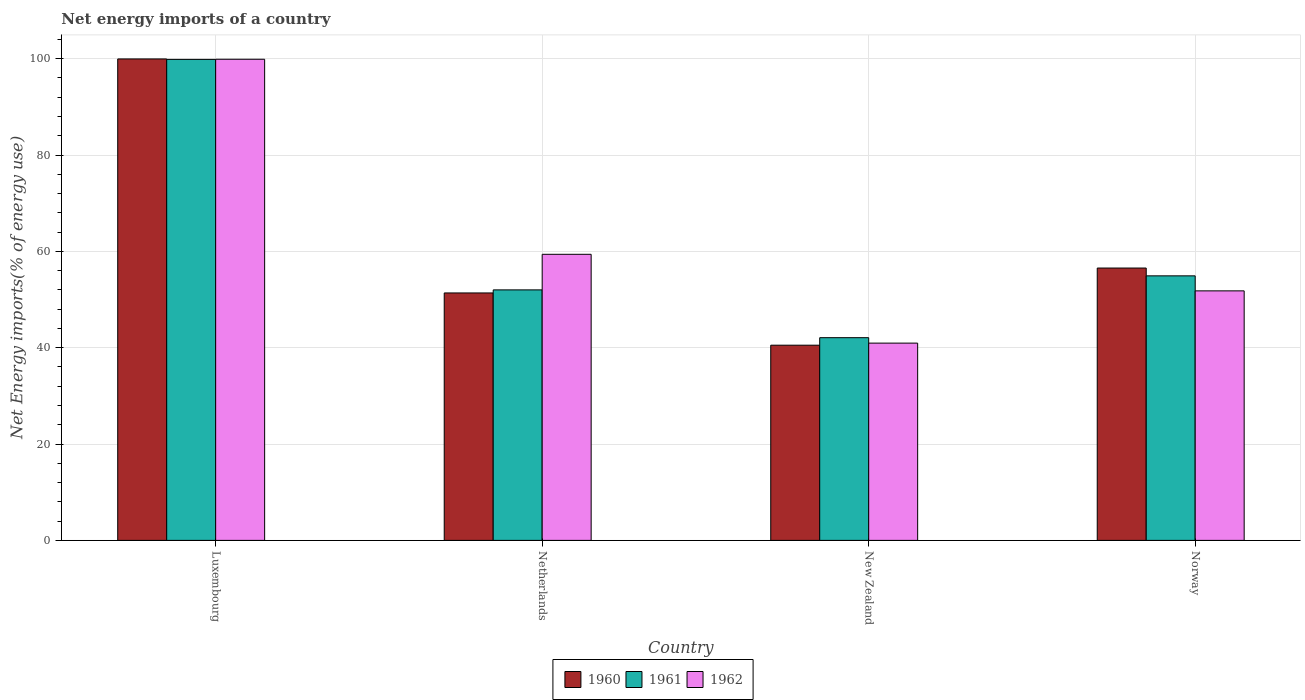How many different coloured bars are there?
Make the answer very short. 3. How many groups of bars are there?
Offer a terse response. 4. Are the number of bars on each tick of the X-axis equal?
Give a very brief answer. Yes. How many bars are there on the 2nd tick from the left?
Make the answer very short. 3. How many bars are there on the 2nd tick from the right?
Provide a succinct answer. 3. What is the label of the 1st group of bars from the left?
Keep it short and to the point. Luxembourg. What is the net energy imports in 1960 in Luxembourg?
Offer a terse response. 99.95. Across all countries, what is the maximum net energy imports in 1962?
Offer a terse response. 99.88. Across all countries, what is the minimum net energy imports in 1962?
Your answer should be very brief. 40.95. In which country was the net energy imports in 1960 maximum?
Make the answer very short. Luxembourg. In which country was the net energy imports in 1962 minimum?
Provide a short and direct response. New Zealand. What is the total net energy imports in 1961 in the graph?
Ensure brevity in your answer.  248.86. What is the difference between the net energy imports in 1961 in Luxembourg and that in Norway?
Provide a short and direct response. 44.94. What is the difference between the net energy imports in 1961 in Netherlands and the net energy imports in 1962 in Luxembourg?
Your answer should be compact. -47.88. What is the average net energy imports in 1961 per country?
Make the answer very short. 62.21. What is the difference between the net energy imports of/in 1962 and net energy imports of/in 1960 in Norway?
Your answer should be compact. -4.74. What is the ratio of the net energy imports in 1961 in Luxembourg to that in Norway?
Your response must be concise. 1.82. Is the difference between the net energy imports in 1962 in Luxembourg and Norway greater than the difference between the net energy imports in 1960 in Luxembourg and Norway?
Provide a short and direct response. Yes. What is the difference between the highest and the second highest net energy imports in 1960?
Offer a terse response. 5.17. What is the difference between the highest and the lowest net energy imports in 1961?
Offer a very short reply. 57.77. Is the sum of the net energy imports in 1960 in Netherlands and New Zealand greater than the maximum net energy imports in 1962 across all countries?
Offer a terse response. No. What does the 3rd bar from the left in Netherlands represents?
Ensure brevity in your answer.  1962. How many bars are there?
Your answer should be compact. 12. What is the difference between two consecutive major ticks on the Y-axis?
Your answer should be compact. 20. Are the values on the major ticks of Y-axis written in scientific E-notation?
Your answer should be compact. No. Does the graph contain grids?
Your answer should be compact. Yes. Where does the legend appear in the graph?
Provide a short and direct response. Bottom center. What is the title of the graph?
Your answer should be compact. Net energy imports of a country. What is the label or title of the Y-axis?
Provide a succinct answer. Net Energy imports(% of energy use). What is the Net Energy imports(% of energy use) of 1960 in Luxembourg?
Offer a very short reply. 99.95. What is the Net Energy imports(% of energy use) of 1961 in Luxembourg?
Provide a short and direct response. 99.85. What is the Net Energy imports(% of energy use) of 1962 in Luxembourg?
Ensure brevity in your answer.  99.88. What is the Net Energy imports(% of energy use) of 1960 in Netherlands?
Give a very brief answer. 51.37. What is the Net Energy imports(% of energy use) in 1961 in Netherlands?
Your answer should be compact. 52. What is the Net Energy imports(% of energy use) of 1962 in Netherlands?
Provide a succinct answer. 59.39. What is the Net Energy imports(% of energy use) in 1960 in New Zealand?
Provide a short and direct response. 40.52. What is the Net Energy imports(% of energy use) of 1961 in New Zealand?
Your response must be concise. 42.08. What is the Net Energy imports(% of energy use) in 1962 in New Zealand?
Your answer should be very brief. 40.95. What is the Net Energy imports(% of energy use) in 1960 in Norway?
Offer a terse response. 56.54. What is the Net Energy imports(% of energy use) of 1961 in Norway?
Ensure brevity in your answer.  54.92. What is the Net Energy imports(% of energy use) in 1962 in Norway?
Your answer should be compact. 51.8. Across all countries, what is the maximum Net Energy imports(% of energy use) in 1960?
Offer a very short reply. 99.95. Across all countries, what is the maximum Net Energy imports(% of energy use) in 1961?
Your response must be concise. 99.85. Across all countries, what is the maximum Net Energy imports(% of energy use) of 1962?
Make the answer very short. 99.88. Across all countries, what is the minimum Net Energy imports(% of energy use) of 1960?
Make the answer very short. 40.52. Across all countries, what is the minimum Net Energy imports(% of energy use) of 1961?
Offer a terse response. 42.08. Across all countries, what is the minimum Net Energy imports(% of energy use) of 1962?
Ensure brevity in your answer.  40.95. What is the total Net Energy imports(% of energy use) of 1960 in the graph?
Your response must be concise. 248.38. What is the total Net Energy imports(% of energy use) in 1961 in the graph?
Your answer should be compact. 248.86. What is the total Net Energy imports(% of energy use) of 1962 in the graph?
Keep it short and to the point. 252.03. What is the difference between the Net Energy imports(% of energy use) in 1960 in Luxembourg and that in Netherlands?
Provide a short and direct response. 48.58. What is the difference between the Net Energy imports(% of energy use) in 1961 in Luxembourg and that in Netherlands?
Keep it short and to the point. 47.85. What is the difference between the Net Energy imports(% of energy use) of 1962 in Luxembourg and that in Netherlands?
Your answer should be compact. 40.49. What is the difference between the Net Energy imports(% of energy use) of 1960 in Luxembourg and that in New Zealand?
Keep it short and to the point. 59.43. What is the difference between the Net Energy imports(% of energy use) in 1961 in Luxembourg and that in New Zealand?
Provide a succinct answer. 57.77. What is the difference between the Net Energy imports(% of energy use) in 1962 in Luxembourg and that in New Zealand?
Provide a succinct answer. 58.93. What is the difference between the Net Energy imports(% of energy use) in 1960 in Luxembourg and that in Norway?
Provide a short and direct response. 43.41. What is the difference between the Net Energy imports(% of energy use) of 1961 in Luxembourg and that in Norway?
Your response must be concise. 44.94. What is the difference between the Net Energy imports(% of energy use) in 1962 in Luxembourg and that in Norway?
Keep it short and to the point. 48.08. What is the difference between the Net Energy imports(% of energy use) in 1960 in Netherlands and that in New Zealand?
Provide a short and direct response. 10.85. What is the difference between the Net Energy imports(% of energy use) of 1961 in Netherlands and that in New Zealand?
Keep it short and to the point. 9.92. What is the difference between the Net Energy imports(% of energy use) of 1962 in Netherlands and that in New Zealand?
Your answer should be very brief. 18.44. What is the difference between the Net Energy imports(% of energy use) in 1960 in Netherlands and that in Norway?
Provide a short and direct response. -5.17. What is the difference between the Net Energy imports(% of energy use) of 1961 in Netherlands and that in Norway?
Your response must be concise. -2.91. What is the difference between the Net Energy imports(% of energy use) of 1962 in Netherlands and that in Norway?
Your answer should be very brief. 7.59. What is the difference between the Net Energy imports(% of energy use) in 1960 in New Zealand and that in Norway?
Offer a terse response. -16.02. What is the difference between the Net Energy imports(% of energy use) of 1961 in New Zealand and that in Norway?
Your answer should be very brief. -12.83. What is the difference between the Net Energy imports(% of energy use) in 1962 in New Zealand and that in Norway?
Ensure brevity in your answer.  -10.85. What is the difference between the Net Energy imports(% of energy use) of 1960 in Luxembourg and the Net Energy imports(% of energy use) of 1961 in Netherlands?
Provide a succinct answer. 47.94. What is the difference between the Net Energy imports(% of energy use) in 1960 in Luxembourg and the Net Energy imports(% of energy use) in 1962 in Netherlands?
Offer a terse response. 40.56. What is the difference between the Net Energy imports(% of energy use) in 1961 in Luxembourg and the Net Energy imports(% of energy use) in 1962 in Netherlands?
Keep it short and to the point. 40.46. What is the difference between the Net Energy imports(% of energy use) of 1960 in Luxembourg and the Net Energy imports(% of energy use) of 1961 in New Zealand?
Your answer should be very brief. 57.87. What is the difference between the Net Energy imports(% of energy use) of 1960 in Luxembourg and the Net Energy imports(% of energy use) of 1962 in New Zealand?
Your answer should be compact. 58.99. What is the difference between the Net Energy imports(% of energy use) in 1961 in Luxembourg and the Net Energy imports(% of energy use) in 1962 in New Zealand?
Your answer should be compact. 58.9. What is the difference between the Net Energy imports(% of energy use) in 1960 in Luxembourg and the Net Energy imports(% of energy use) in 1961 in Norway?
Ensure brevity in your answer.  45.03. What is the difference between the Net Energy imports(% of energy use) of 1960 in Luxembourg and the Net Energy imports(% of energy use) of 1962 in Norway?
Make the answer very short. 48.15. What is the difference between the Net Energy imports(% of energy use) of 1961 in Luxembourg and the Net Energy imports(% of energy use) of 1962 in Norway?
Offer a very short reply. 48.05. What is the difference between the Net Energy imports(% of energy use) of 1960 in Netherlands and the Net Energy imports(% of energy use) of 1961 in New Zealand?
Provide a succinct answer. 9.29. What is the difference between the Net Energy imports(% of energy use) in 1960 in Netherlands and the Net Energy imports(% of energy use) in 1962 in New Zealand?
Your answer should be compact. 10.42. What is the difference between the Net Energy imports(% of energy use) of 1961 in Netherlands and the Net Energy imports(% of energy use) of 1962 in New Zealand?
Your answer should be very brief. 11.05. What is the difference between the Net Energy imports(% of energy use) of 1960 in Netherlands and the Net Energy imports(% of energy use) of 1961 in Norway?
Your answer should be very brief. -3.55. What is the difference between the Net Energy imports(% of energy use) of 1960 in Netherlands and the Net Energy imports(% of energy use) of 1962 in Norway?
Offer a very short reply. -0.43. What is the difference between the Net Energy imports(% of energy use) in 1961 in Netherlands and the Net Energy imports(% of energy use) in 1962 in Norway?
Your answer should be compact. 0.2. What is the difference between the Net Energy imports(% of energy use) in 1960 in New Zealand and the Net Energy imports(% of energy use) in 1961 in Norway?
Provide a short and direct response. -14.39. What is the difference between the Net Energy imports(% of energy use) of 1960 in New Zealand and the Net Energy imports(% of energy use) of 1962 in Norway?
Give a very brief answer. -11.28. What is the difference between the Net Energy imports(% of energy use) in 1961 in New Zealand and the Net Energy imports(% of energy use) in 1962 in Norway?
Offer a terse response. -9.72. What is the average Net Energy imports(% of energy use) of 1960 per country?
Provide a succinct answer. 62.09. What is the average Net Energy imports(% of energy use) of 1961 per country?
Provide a succinct answer. 62.21. What is the average Net Energy imports(% of energy use) in 1962 per country?
Offer a very short reply. 63.01. What is the difference between the Net Energy imports(% of energy use) of 1960 and Net Energy imports(% of energy use) of 1961 in Luxembourg?
Keep it short and to the point. 0.09. What is the difference between the Net Energy imports(% of energy use) of 1960 and Net Energy imports(% of energy use) of 1962 in Luxembourg?
Offer a terse response. 0.06. What is the difference between the Net Energy imports(% of energy use) of 1961 and Net Energy imports(% of energy use) of 1962 in Luxembourg?
Ensure brevity in your answer.  -0.03. What is the difference between the Net Energy imports(% of energy use) in 1960 and Net Energy imports(% of energy use) in 1961 in Netherlands?
Provide a short and direct response. -0.64. What is the difference between the Net Energy imports(% of energy use) of 1960 and Net Energy imports(% of energy use) of 1962 in Netherlands?
Give a very brief answer. -8.02. What is the difference between the Net Energy imports(% of energy use) of 1961 and Net Energy imports(% of energy use) of 1962 in Netherlands?
Provide a succinct answer. -7.39. What is the difference between the Net Energy imports(% of energy use) in 1960 and Net Energy imports(% of energy use) in 1961 in New Zealand?
Provide a short and direct response. -1.56. What is the difference between the Net Energy imports(% of energy use) of 1960 and Net Energy imports(% of energy use) of 1962 in New Zealand?
Your answer should be very brief. -0.43. What is the difference between the Net Energy imports(% of energy use) of 1961 and Net Energy imports(% of energy use) of 1962 in New Zealand?
Ensure brevity in your answer.  1.13. What is the difference between the Net Energy imports(% of energy use) in 1960 and Net Energy imports(% of energy use) in 1961 in Norway?
Give a very brief answer. 1.62. What is the difference between the Net Energy imports(% of energy use) in 1960 and Net Energy imports(% of energy use) in 1962 in Norway?
Make the answer very short. 4.74. What is the difference between the Net Energy imports(% of energy use) of 1961 and Net Energy imports(% of energy use) of 1962 in Norway?
Your answer should be very brief. 3.12. What is the ratio of the Net Energy imports(% of energy use) of 1960 in Luxembourg to that in Netherlands?
Give a very brief answer. 1.95. What is the ratio of the Net Energy imports(% of energy use) of 1961 in Luxembourg to that in Netherlands?
Provide a succinct answer. 1.92. What is the ratio of the Net Energy imports(% of energy use) in 1962 in Luxembourg to that in Netherlands?
Offer a terse response. 1.68. What is the ratio of the Net Energy imports(% of energy use) in 1960 in Luxembourg to that in New Zealand?
Offer a terse response. 2.47. What is the ratio of the Net Energy imports(% of energy use) of 1961 in Luxembourg to that in New Zealand?
Offer a very short reply. 2.37. What is the ratio of the Net Energy imports(% of energy use) of 1962 in Luxembourg to that in New Zealand?
Ensure brevity in your answer.  2.44. What is the ratio of the Net Energy imports(% of energy use) of 1960 in Luxembourg to that in Norway?
Give a very brief answer. 1.77. What is the ratio of the Net Energy imports(% of energy use) of 1961 in Luxembourg to that in Norway?
Your answer should be compact. 1.82. What is the ratio of the Net Energy imports(% of energy use) of 1962 in Luxembourg to that in Norway?
Keep it short and to the point. 1.93. What is the ratio of the Net Energy imports(% of energy use) in 1960 in Netherlands to that in New Zealand?
Provide a succinct answer. 1.27. What is the ratio of the Net Energy imports(% of energy use) of 1961 in Netherlands to that in New Zealand?
Keep it short and to the point. 1.24. What is the ratio of the Net Energy imports(% of energy use) of 1962 in Netherlands to that in New Zealand?
Make the answer very short. 1.45. What is the ratio of the Net Energy imports(% of energy use) in 1960 in Netherlands to that in Norway?
Offer a terse response. 0.91. What is the ratio of the Net Energy imports(% of energy use) in 1961 in Netherlands to that in Norway?
Offer a very short reply. 0.95. What is the ratio of the Net Energy imports(% of energy use) in 1962 in Netherlands to that in Norway?
Keep it short and to the point. 1.15. What is the ratio of the Net Energy imports(% of energy use) of 1960 in New Zealand to that in Norway?
Make the answer very short. 0.72. What is the ratio of the Net Energy imports(% of energy use) in 1961 in New Zealand to that in Norway?
Provide a short and direct response. 0.77. What is the ratio of the Net Energy imports(% of energy use) in 1962 in New Zealand to that in Norway?
Keep it short and to the point. 0.79. What is the difference between the highest and the second highest Net Energy imports(% of energy use) in 1960?
Offer a terse response. 43.41. What is the difference between the highest and the second highest Net Energy imports(% of energy use) in 1961?
Make the answer very short. 44.94. What is the difference between the highest and the second highest Net Energy imports(% of energy use) in 1962?
Ensure brevity in your answer.  40.49. What is the difference between the highest and the lowest Net Energy imports(% of energy use) in 1960?
Ensure brevity in your answer.  59.43. What is the difference between the highest and the lowest Net Energy imports(% of energy use) of 1961?
Give a very brief answer. 57.77. What is the difference between the highest and the lowest Net Energy imports(% of energy use) in 1962?
Your response must be concise. 58.93. 